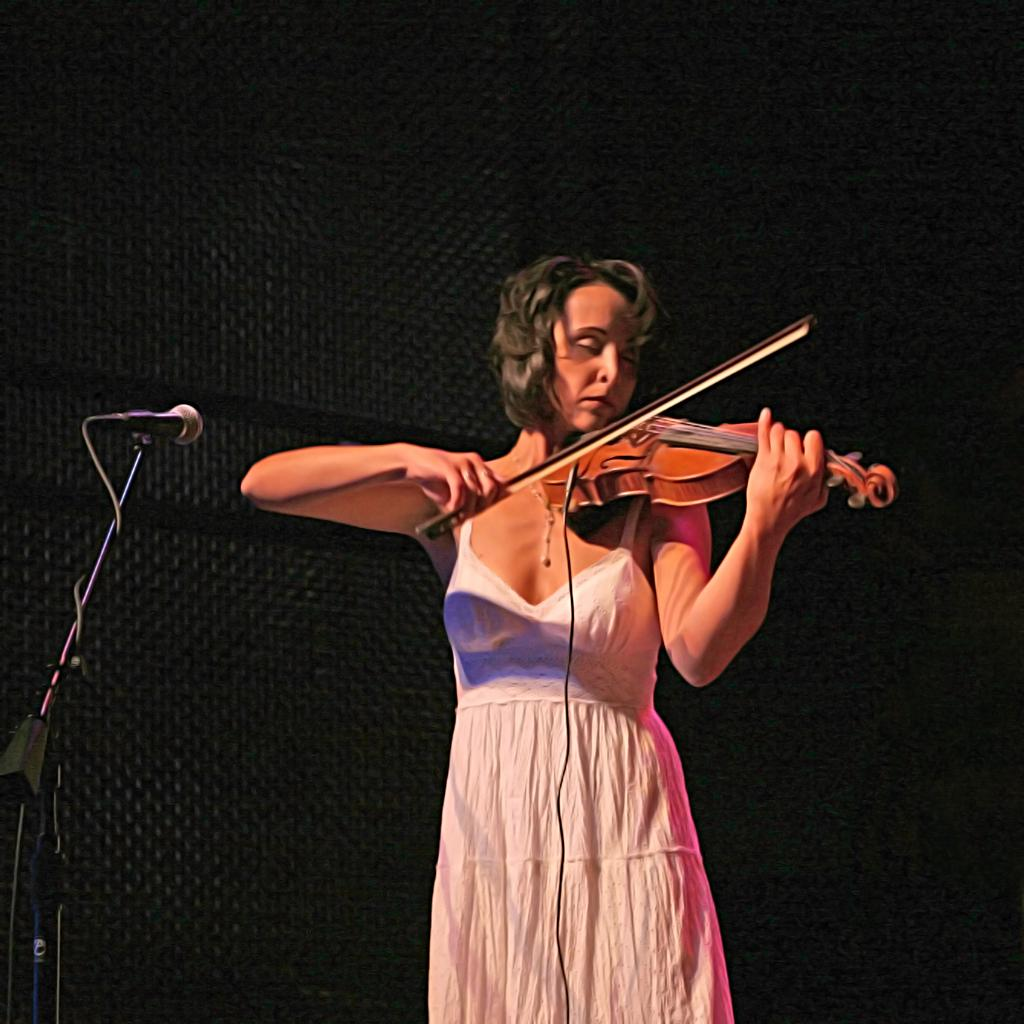Who is the main subject in the image? There is a woman in the image. What is the woman wearing? The woman is wearing a white dress. What is the woman holding in the image? The woman is holding a guitar. What is the woman doing with the guitar? The woman is playing the guitar. What other object can be seen in the image related to the woman's activity? There is a microphone in the image. What type of underwear is the woman wearing in the image? There is no information about the woman's underwear in the image, and therefore it cannot be determined. 